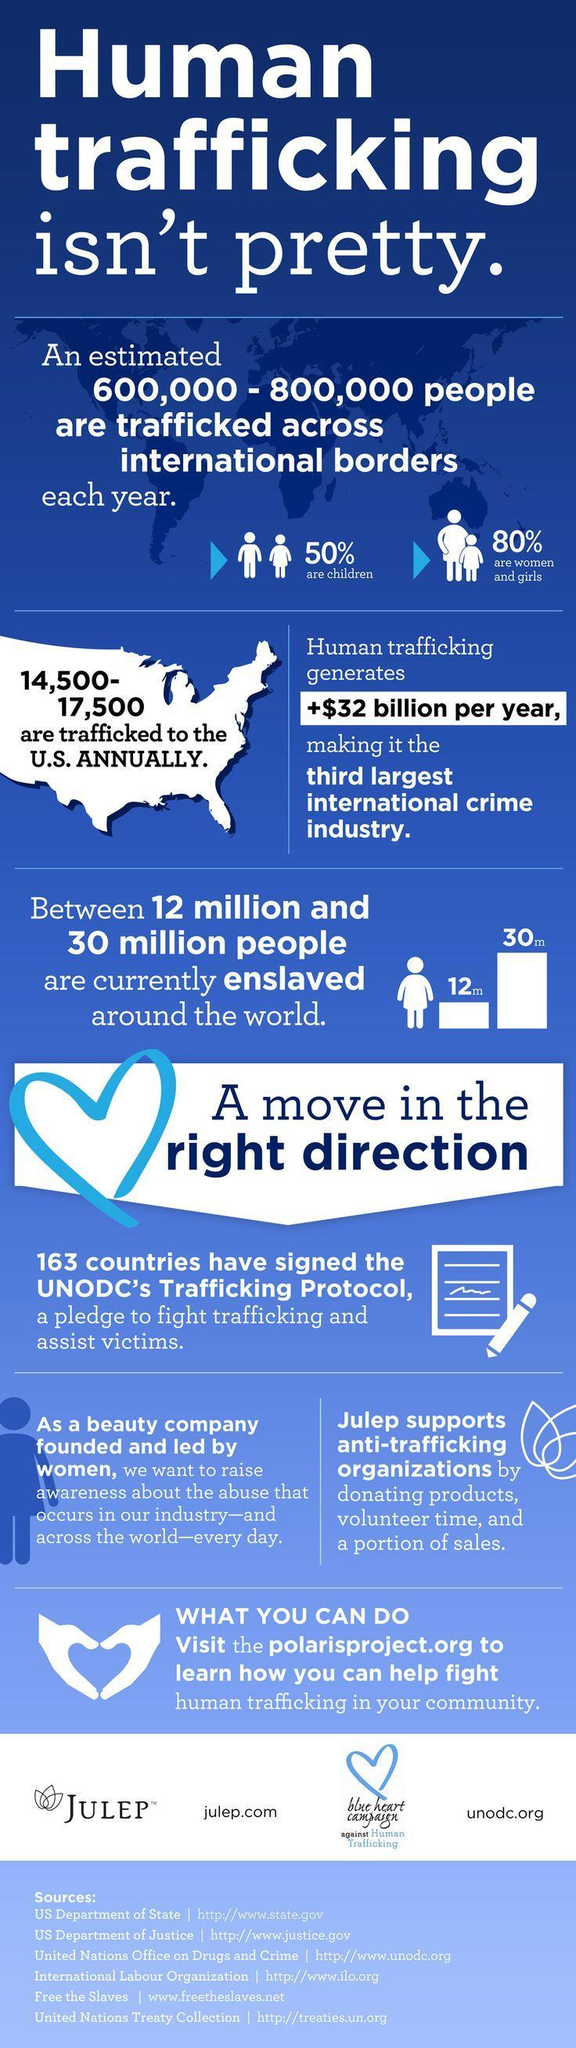what is the third largest international crime industry
Answer the question with a short phrase. human trafficking what is the count of which 50% are children 600,000 - 800,000 Which is the beauty company mentioned Julep what is the count of which 80% are women and girls 600,000 - 800,000 What is the human trafficking revenue +$32 billion per year 